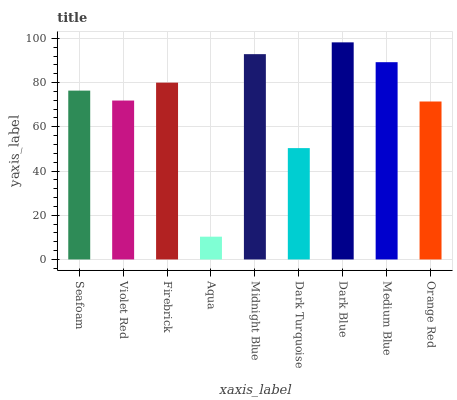Is Aqua the minimum?
Answer yes or no. Yes. Is Dark Blue the maximum?
Answer yes or no. Yes. Is Violet Red the minimum?
Answer yes or no. No. Is Violet Red the maximum?
Answer yes or no. No. Is Seafoam greater than Violet Red?
Answer yes or no. Yes. Is Violet Red less than Seafoam?
Answer yes or no. Yes. Is Violet Red greater than Seafoam?
Answer yes or no. No. Is Seafoam less than Violet Red?
Answer yes or no. No. Is Seafoam the high median?
Answer yes or no. Yes. Is Seafoam the low median?
Answer yes or no. Yes. Is Dark Blue the high median?
Answer yes or no. No. Is Aqua the low median?
Answer yes or no. No. 